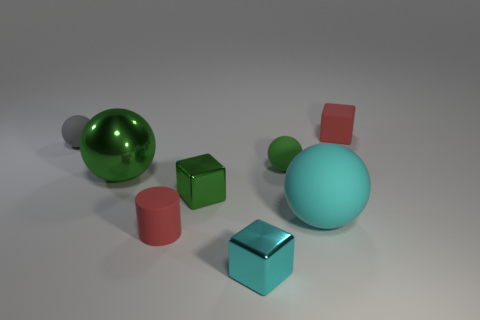There is a red object that is the same size as the red cylinder; what is its material?
Your answer should be very brief. Rubber. What material is the block that is the same color as the metal sphere?
Keep it short and to the point. Metal. What is the shape of the green object that is right of the green cube?
Ensure brevity in your answer.  Sphere. What number of large things are either metal balls or metal blocks?
Make the answer very short. 1. There is a cyan shiny thing; what number of blocks are right of it?
Provide a short and direct response. 1. The other metal object that is the same shape as the tiny cyan shiny thing is what color?
Make the answer very short. Green. What number of shiny things are tiny blocks or big brown cylinders?
Provide a short and direct response. 2. Are there any small red cubes that are to the left of the cyan matte object that is to the right of the red rubber thing that is left of the cyan cube?
Make the answer very short. No. The matte cylinder has what color?
Offer a very short reply. Red. Does the red rubber thing that is behind the small green sphere have the same shape as the tiny green shiny thing?
Provide a short and direct response. Yes. 